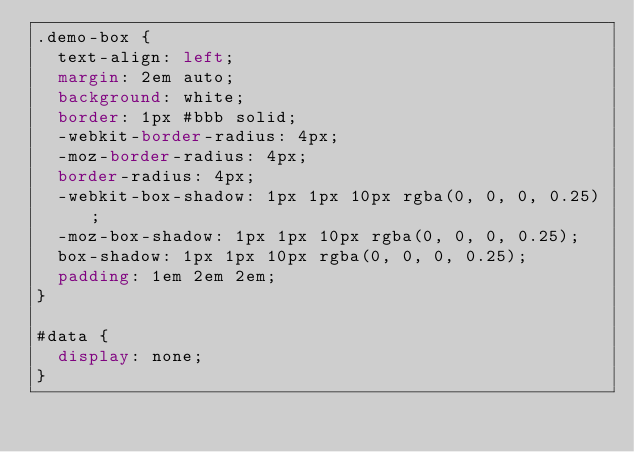<code> <loc_0><loc_0><loc_500><loc_500><_CSS_>.demo-box {
  text-align: left;
  margin: 2em auto;
  background: white;
  border: 1px #bbb solid;
  -webkit-border-radius: 4px;
  -moz-border-radius: 4px;
  border-radius: 4px;
  -webkit-box-shadow: 1px 1px 10px rgba(0, 0, 0, 0.25);
  -moz-box-shadow: 1px 1px 10px rgba(0, 0, 0, 0.25);
  box-shadow: 1px 1px 10px rgba(0, 0, 0, 0.25);
  padding: 1em 2em 2em;
}

#data {
  display: none;
}</code> 